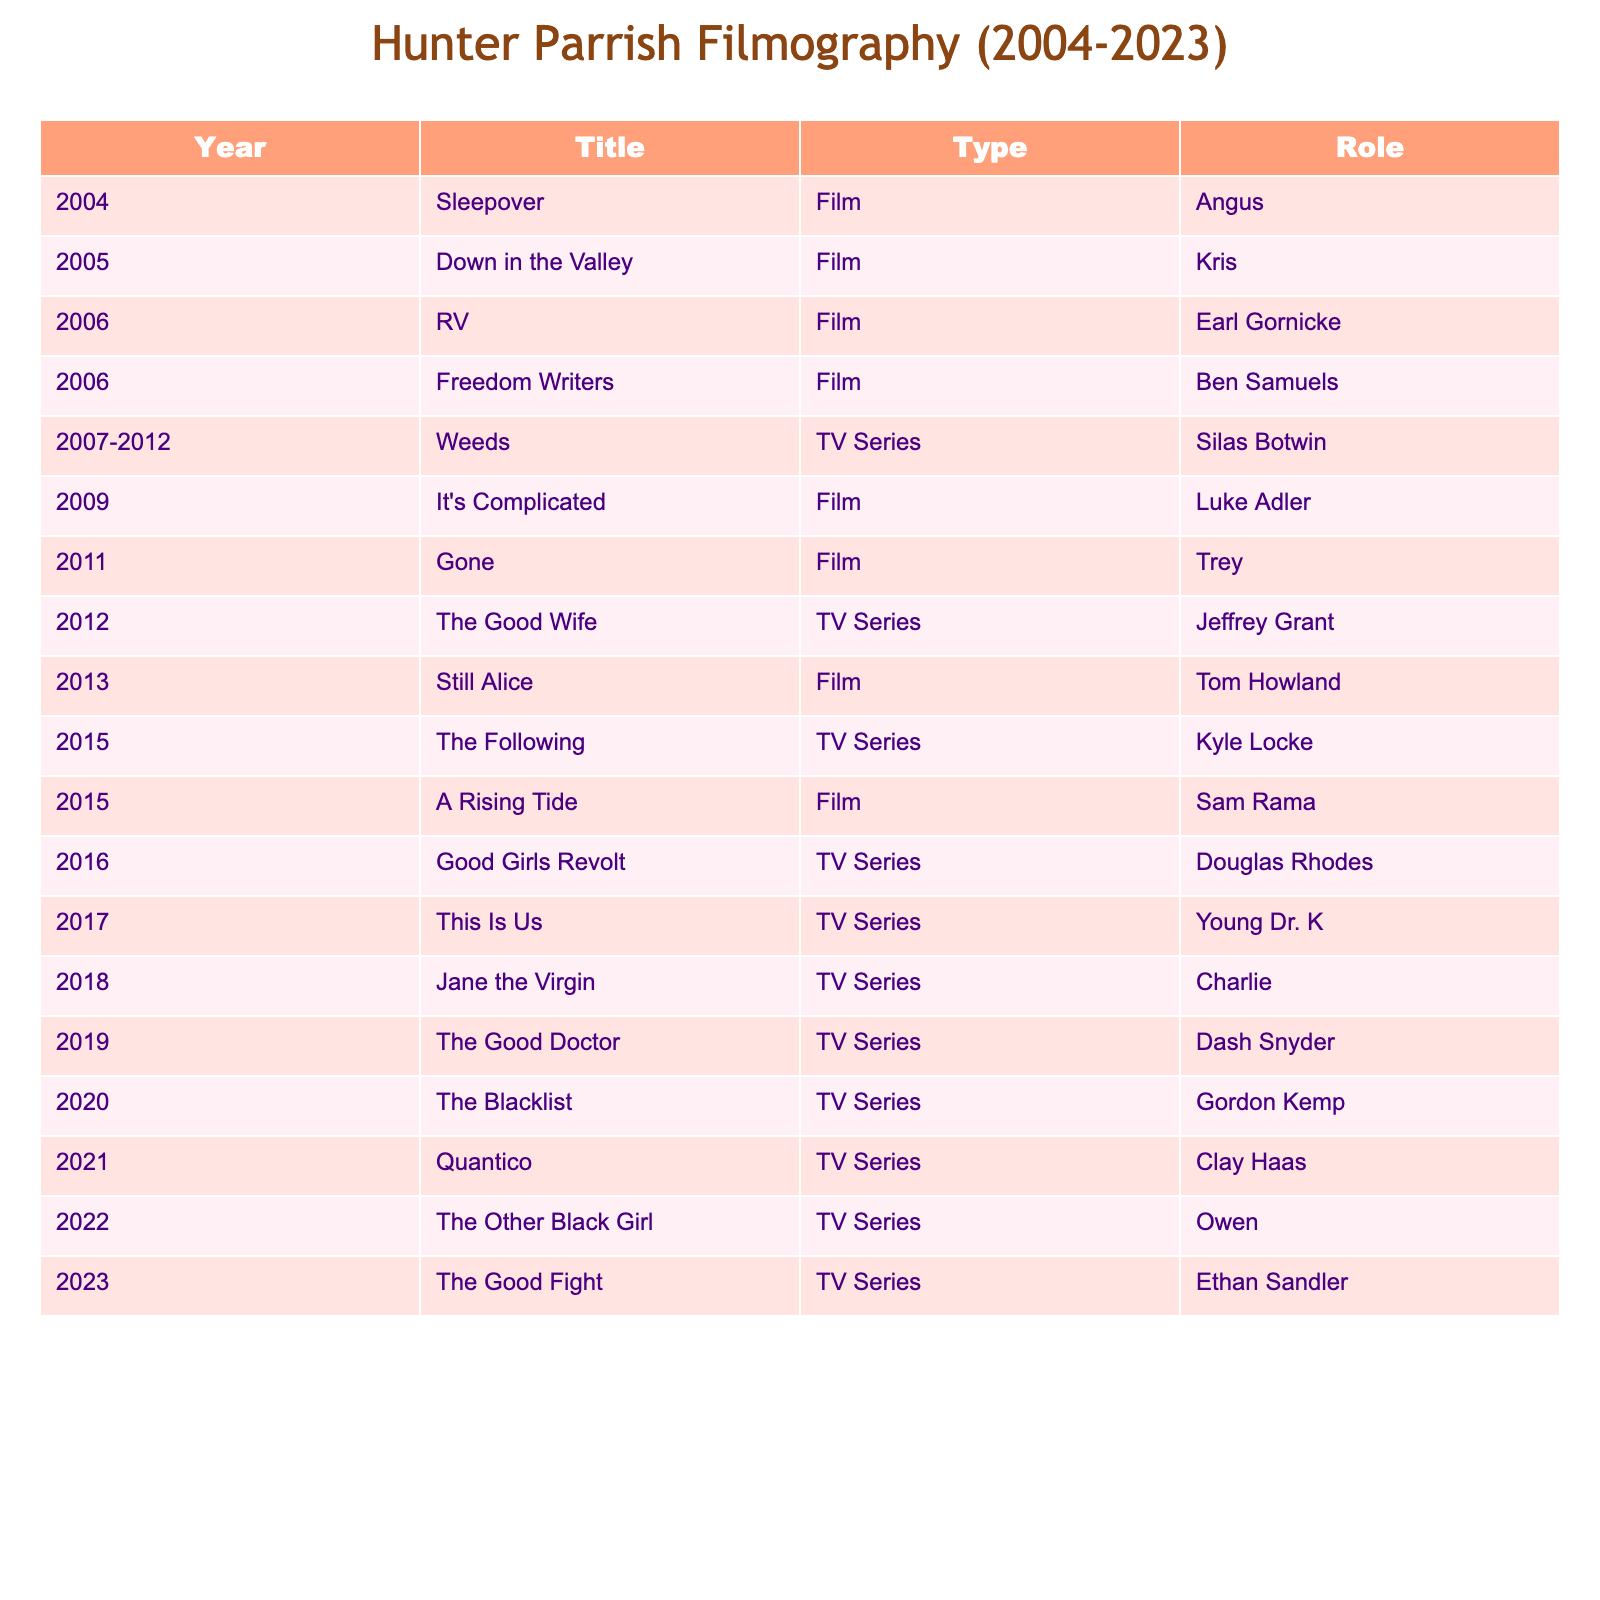What film did Hunter Parrish appear in in 2006? The table lists Hunter Parrish's filmography and TV appearances. In 2006, he starred in "RV" as Earl Gornicke and "Freedom Writers" as Ben Samuels.
Answer: "RV" and "Freedom Writers" How many TV series has Hunter Parrish appeared in from 2004 to 2023? By counting the entries categorized as "TV Series" in the Type column, we find that there are 9 instances.
Answer: 9 In which year did Hunter Parrish have the longest running TV series? According to the table, "Weeds" was a TV series running from 2007 to 2012, which totals 6 years, making it the longest running.
Answer: 2007 to 2012 Has Hunter Parrish appeared in more films or TV series between 2004 and 2023? The table shows 7 films and 9 TV series, indicating he has appeared in more TV series overall.
Answer: Yes, more TV series What is the total number of film roles Hunter Parrish played after 2015? Hunter Parrish played 3 film roles after 2015: "A Rising Tide" in 2015, "Still Alice" in 2013 (not counted), and "Gone" in 2011 (not counted again). Therefore, the total from 2015 onward is just 1 role.
Answer: 1 Which character did Hunter Parrish portray in "Jane the Virgin"? Referring to the table, he played the character Charlie in the TV series "Jane the Virgin," which aired in 2018.
Answer: Charlie During which years did Hunter Parrish participate in his first and last TV series? His first TV series was "Weeds" from 2007 to 2012, and his last was "The Good Fight" in 2023. So, he participated in TV series from 2007 to 2023.
Answer: 2007 to 2023 What is the ratio of films to TV series in Hunter Parrish's filmography from 2004 to 2023? There are 7 films and 9 TV series in the table. The ratio of films to TV series is 7:9.
Answer: 7:9 Which role in a film did Hunter Parrish take on in 2019? The table does not list any film role for Hunter Parrish in 2019; instead, he appeared in a TV series titled "The Good Doctor" that year.
Answer: No film role in 2019 Has Hunter Parrish had more roles in dramas or comedies based on the titles listed? The titles suggest that many are dramas (e.g., "Still Alice," "Freedom Writers") and some are comedies (e.g., "RV," "It's Complicated"). Assessing the roles, dramas appear to outnumber comedies in his filmography.
Answer: Yes, more dramatic roles 